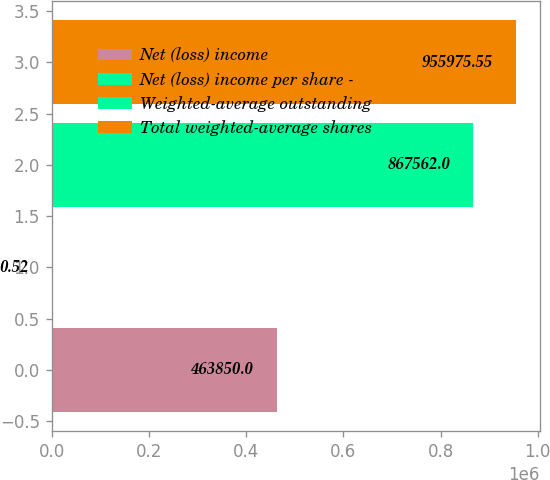<chart> <loc_0><loc_0><loc_500><loc_500><bar_chart><fcel>Net (loss) income<fcel>Net (loss) income per share -<fcel>Weighted-average outstanding<fcel>Total weighted-average shares<nl><fcel>463850<fcel>0.52<fcel>867562<fcel>955976<nl></chart> 